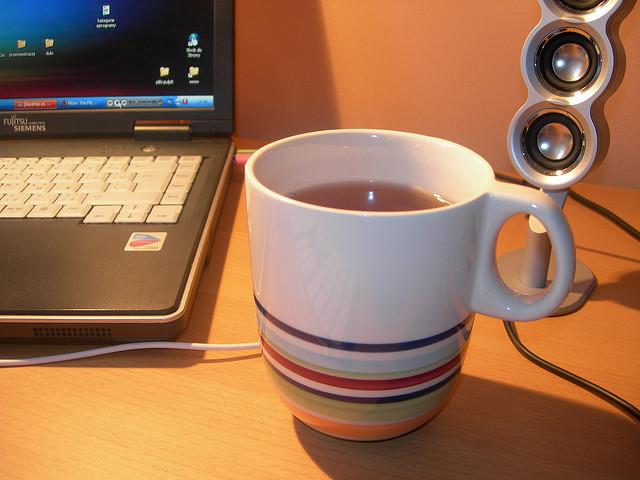How many different colors are on the mug?
Quick response, please. 7. By itself, the handle on the cup looks like half of a what?
Be succinct. 8. Is there anything in the mug?
Be succinct. Yes. Is this a desktop computer?
Concise answer only. No. 